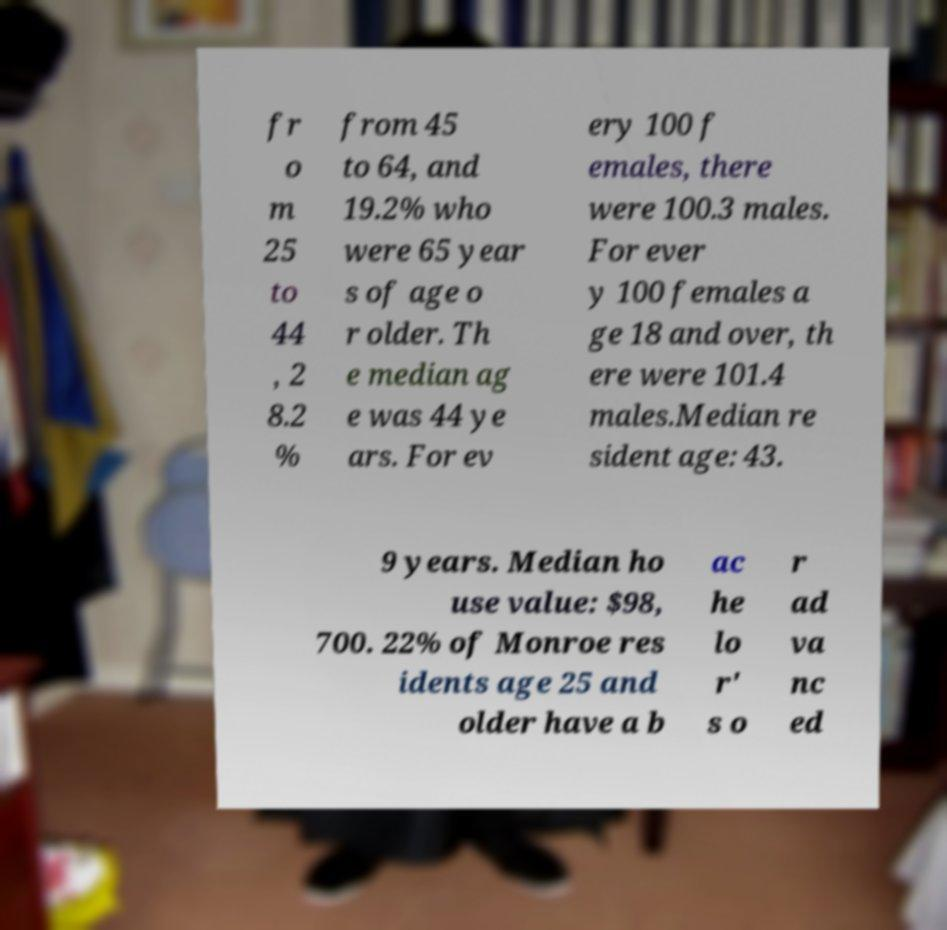For documentation purposes, I need the text within this image transcribed. Could you provide that? fr o m 25 to 44 , 2 8.2 % from 45 to 64, and 19.2% who were 65 year s of age o r older. Th e median ag e was 44 ye ars. For ev ery 100 f emales, there were 100.3 males. For ever y 100 females a ge 18 and over, th ere were 101.4 males.Median re sident age: 43. 9 years. Median ho use value: $98, 700. 22% of Monroe res idents age 25 and older have a b ac he lo r' s o r ad va nc ed 